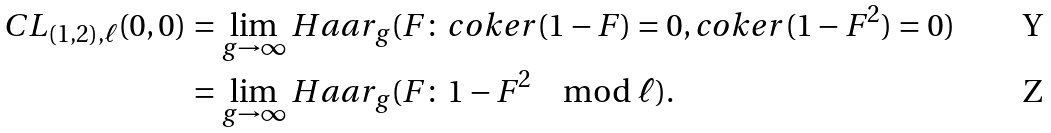<formula> <loc_0><loc_0><loc_500><loc_500>C L _ { ( 1 , 2 ) , \ell } ( 0 , 0 ) & = \lim _ { g \to \infty } H a a r _ { g } ( F \colon c o k e r ( 1 - F ) = 0 , c o k e r ( 1 - F ^ { 2 } ) = 0 ) \\ & = \lim _ { g \to \infty } H a a r _ { g } ( F \colon 1 - F ^ { 2 } \mod \ell ) .</formula> 